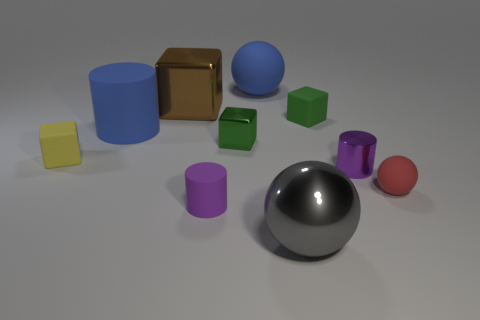Subtract all blue rubber cylinders. How many cylinders are left? 2 Subtract all gray balls. How many green blocks are left? 2 Subtract 1 spheres. How many spheres are left? 2 Subtract all green cubes. How many cubes are left? 2 Subtract 0 gray blocks. How many objects are left? 10 Subtract all balls. How many objects are left? 7 Subtract all blue cylinders. Subtract all gray spheres. How many cylinders are left? 2 Subtract all shiny cubes. Subtract all tiny purple metallic cylinders. How many objects are left? 7 Add 5 big blue objects. How many big blue objects are left? 7 Add 5 large gray balls. How many large gray balls exist? 6 